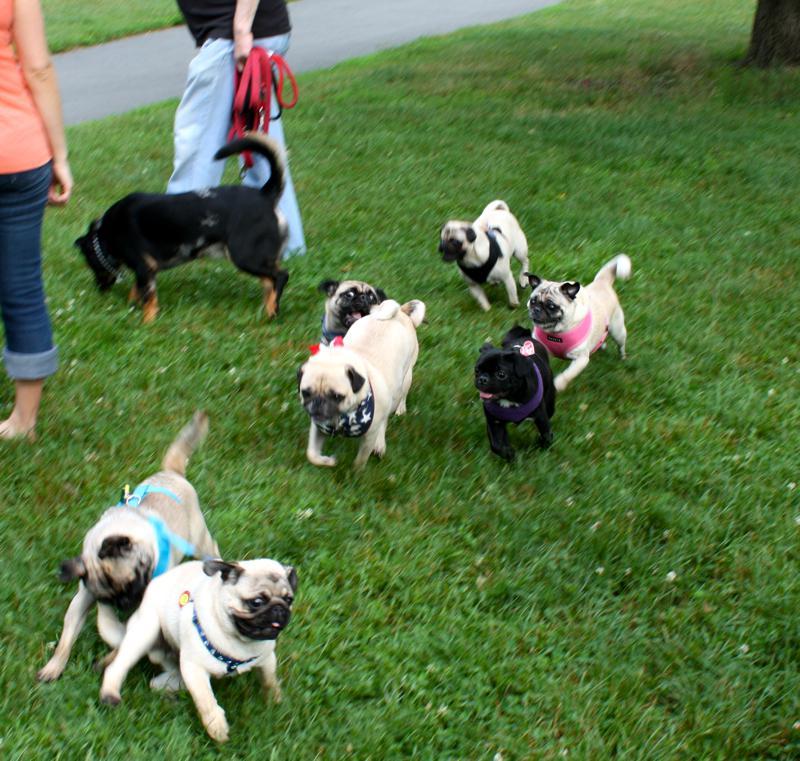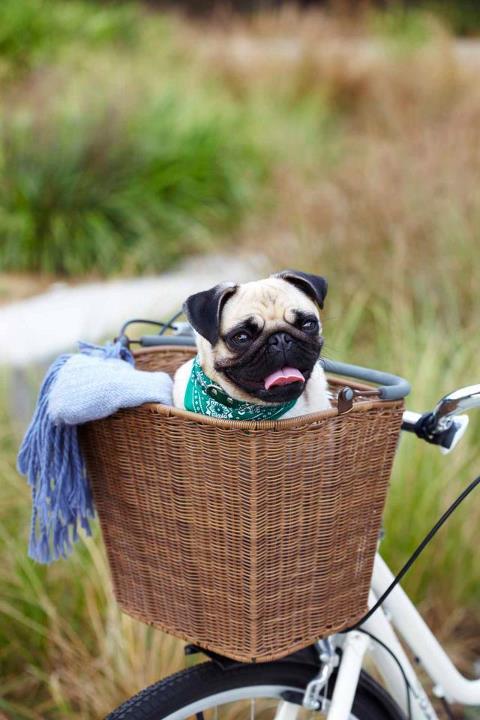The first image is the image on the left, the second image is the image on the right. Examine the images to the left and right. Is the description "There are exactly six tan and black nosed pugs along side two predominately black dogs." accurate? Answer yes or no. Yes. The first image is the image on the left, the second image is the image on the right. Assess this claim about the two images: "In one of the images, you will find only one dog.". Correct or not? Answer yes or no. Yes. 